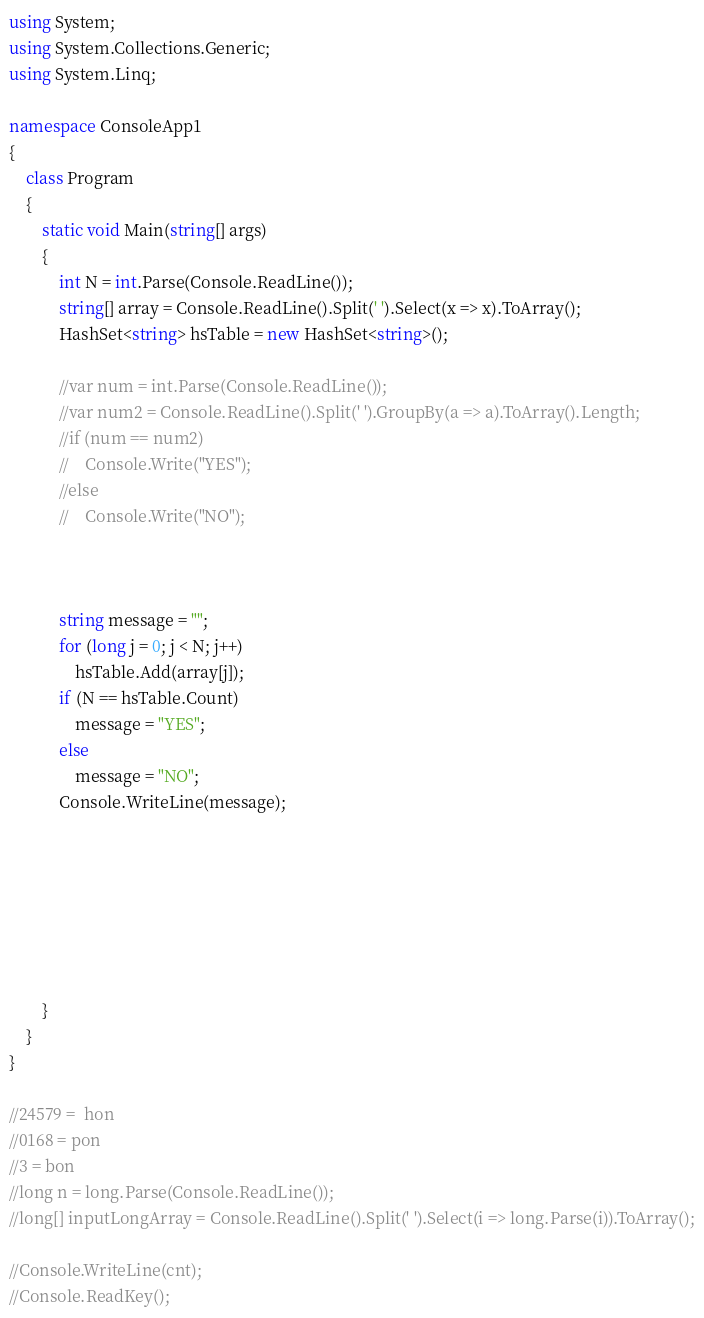<code> <loc_0><loc_0><loc_500><loc_500><_C#_>using System;
using System.Collections.Generic;
using System.Linq;

namespace ConsoleApp1
{
    class Program
    {
        static void Main(string[] args)
        {
            int N = int.Parse(Console.ReadLine());
            string[] array = Console.ReadLine().Split(' ').Select(x => x).ToArray();
            HashSet<string> hsTable = new HashSet<string>();

            //var num = int.Parse(Console.ReadLine());
            //var num2 = Console.ReadLine().Split(' ').GroupBy(a => a).ToArray().Length;
            //if (num == num2)
            //    Console.Write("YES");
            //else
            //    Console.Write("NO");



            string message = "";
            for (long j = 0; j < N; j++)
                hsTable.Add(array[j]);
            if (N == hsTable.Count)
                message = "YES";
            else
                message = "NO";
            Console.WriteLine(message);






           
        }
    }
}

//24579 =  hon
//0168 = pon
//3 = bon
//long n = long.Parse(Console.ReadLine());
//long[] inputLongArray = Console.ReadLine().Split(' ').Select(i => long.Parse(i)).ToArray();

//Console.WriteLine(cnt);
//Console.ReadKey();
</code> 